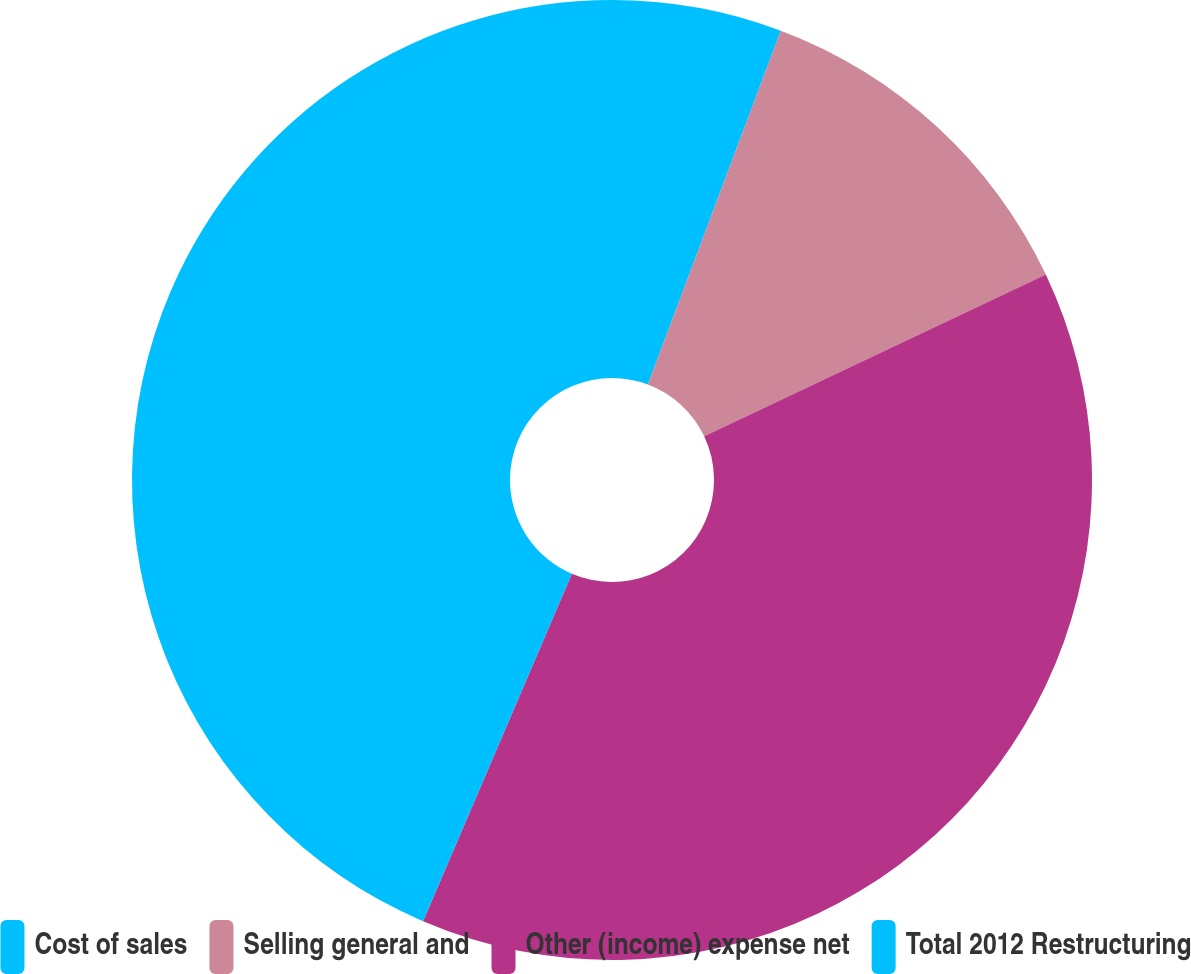<chart> <loc_0><loc_0><loc_500><loc_500><pie_chart><fcel>Cost of sales<fcel>Selling general and<fcel>Other (income) expense net<fcel>Total 2012 Restructuring<nl><fcel>5.72%<fcel>12.24%<fcel>38.48%<fcel>43.56%<nl></chart> 